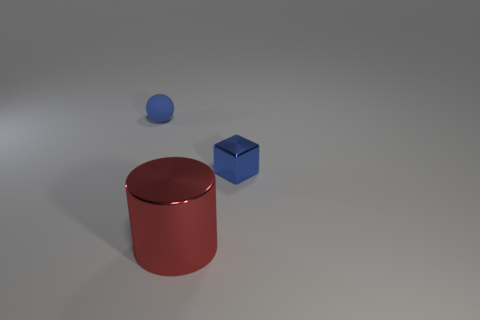Add 2 purple cylinders. How many objects exist? 5 Subtract all balls. How many objects are left? 2 Subtract 0 yellow balls. How many objects are left? 3 Subtract all small blue cubes. Subtract all big cylinders. How many objects are left? 1 Add 1 blue shiny cubes. How many blue shiny cubes are left? 2 Add 2 tiny shiny blocks. How many tiny shiny blocks exist? 3 